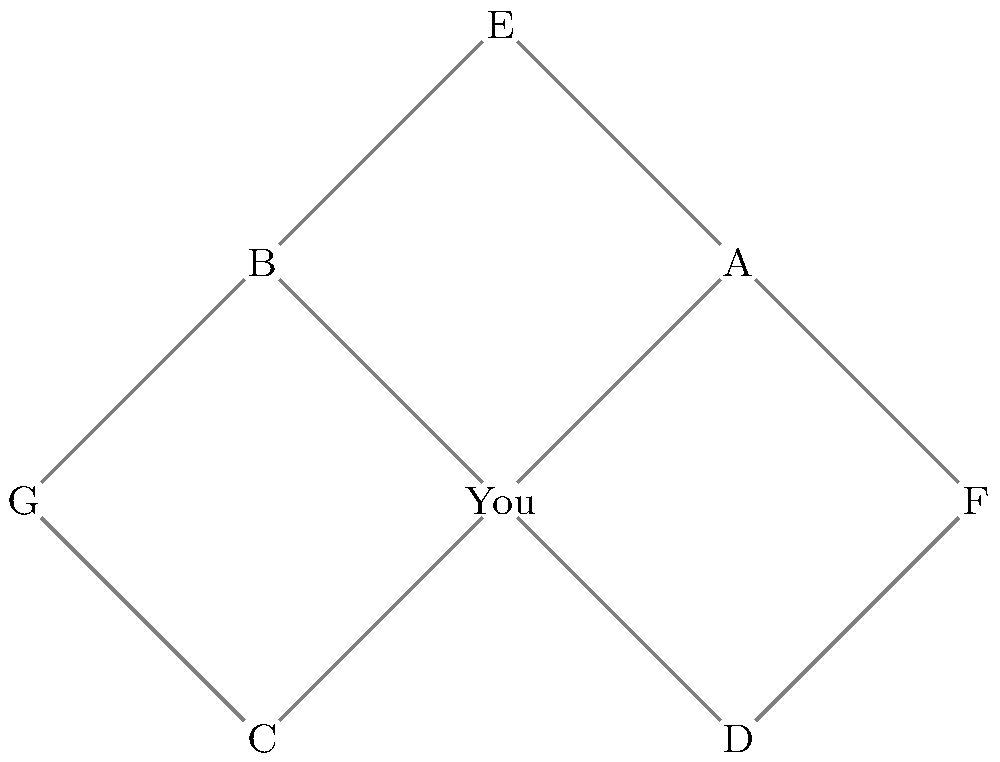You've recently moved to a new military base and want to analyze your social connections using a network graph. The graph above represents your current social network, where you are at the center, and A, B, C, D, E, F, and G represent other individuals in the community. Each line represents a connection between two people. What is the degree centrality of node "You" in this network, and what does it suggest about your position in the community? To solve this problem, we need to follow these steps:

1. Understand degree centrality:
   Degree centrality is a measure of the number of direct connections a node has in a network.

2. Count the connections for the "You" node:
   - "You" is directly connected to A, B, C, and D.
   - The total number of direct connections is 4.

3. Interpret the degree centrality:
   - The degree centrality of "You" is 4.
   - This is the highest degree centrality in the network, as no other node has more direct connections.

4. Analyze the implications:
   - A high degree centrality suggests that "You" is a central figure in this social network.
   - It indicates that you have quickly established multiple connections in your new community.
   - This position could be advantageous for information flow and social support.

5. Consider the network structure:
   - "You" acts as a bridge between different sub-groups (A-E-F, B-E-G, C-G, and D-F).
   - This bridging role further emphasizes your importance in the network.

In graph theory terms, if we denote the degree centrality as $C_D(v)$ for a vertex $v$, and $deg(v)$ as the degree of the vertex, then:

$C_D(v) = deg(v)$

For the "You" node: $C_D(\text{You}) = deg(\text{You}) = 4$
Answer: 4; central position with high connectivity 